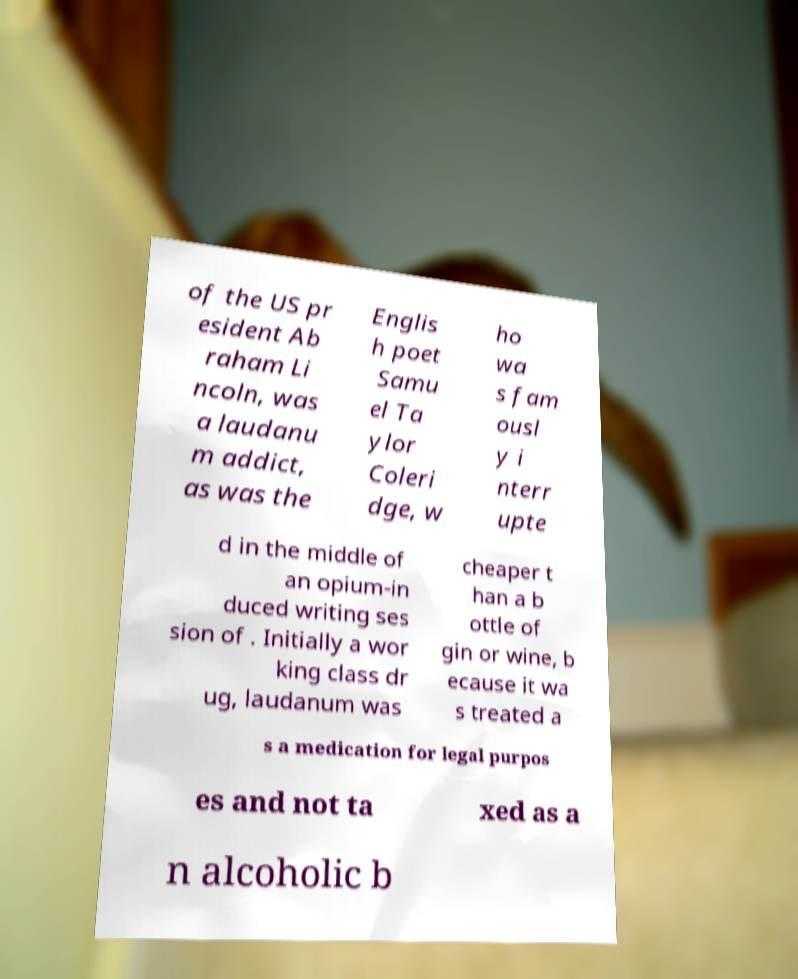Please read and relay the text visible in this image. What does it say? of the US pr esident Ab raham Li ncoln, was a laudanu m addict, as was the Englis h poet Samu el Ta ylor Coleri dge, w ho wa s fam ousl y i nterr upte d in the middle of an opium-in duced writing ses sion of . Initially a wor king class dr ug, laudanum was cheaper t han a b ottle of gin or wine, b ecause it wa s treated a s a medication for legal purpos es and not ta xed as a n alcoholic b 